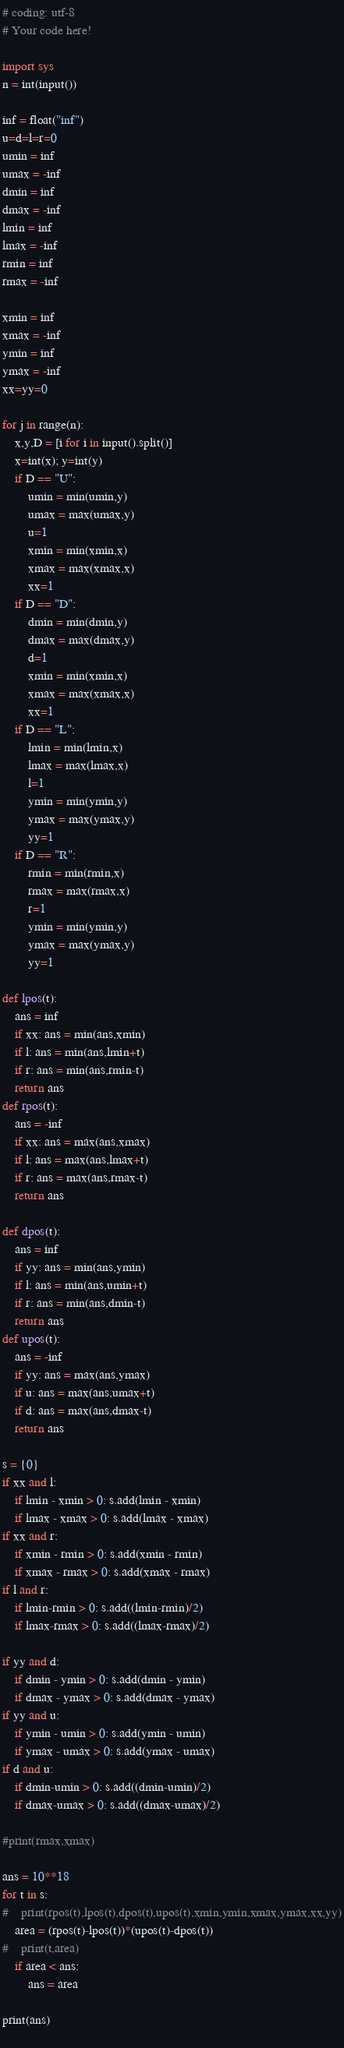Convert code to text. <code><loc_0><loc_0><loc_500><loc_500><_Python_># coding: utf-8
# Your code here!

import sys
n = int(input())

inf = float("inf")
u=d=l=r=0
umin = inf
umax = -inf
dmin = inf
dmax = -inf
lmin = inf
lmax = -inf
rmin = inf
rmax = -inf

xmin = inf
xmax = -inf
ymin = inf
ymax = -inf
xx=yy=0

for j in range(n):
    x,y,D = [i for i in input().split()]
    x=int(x); y=int(y)
    if D == "U":
        umin = min(umin,y)
        umax = max(umax,y)
        u=1
        xmin = min(xmin,x)
        xmax = max(xmax,x)
        xx=1
    if D == "D":
        dmin = min(dmin,y)
        dmax = max(dmax,y)
        d=1
        xmin = min(xmin,x)
        xmax = max(xmax,x)
        xx=1
    if D == "L":
        lmin = min(lmin,x)
        lmax = max(lmax,x)
        l=1
        ymin = min(ymin,y)
        ymax = max(ymax,y)
        yy=1
    if D == "R":
        rmin = min(rmin,x)
        rmax = max(rmax,x)
        r=1
        ymin = min(ymin,y)
        ymax = max(ymax,y)
        yy=1

def lpos(t):
    ans = inf
    if xx: ans = min(ans,xmin)
    if l: ans = min(ans,lmin+t)
    if r: ans = min(ans,rmin-t)
    return ans
def rpos(t):
    ans = -inf
    if xx: ans = max(ans,xmax)
    if l: ans = max(ans,lmax+t)
    if r: ans = max(ans,rmax-t)
    return ans

def dpos(t):
    ans = inf
    if yy: ans = min(ans,ymin)
    if l: ans = min(ans,umin+t)
    if r: ans = min(ans,dmin-t)
    return ans
def upos(t):
    ans = -inf
    if yy: ans = max(ans,ymax)
    if u: ans = max(ans,umax+t)
    if d: ans = max(ans,dmax-t)
    return ans

s = {0}
if xx and l:
    if lmin - xmin > 0: s.add(lmin - xmin)
    if lmax - xmax > 0: s.add(lmax - xmax)
if xx and r:
    if xmin - rmin > 0: s.add(xmin - rmin)
    if xmax - rmax > 0: s.add(xmax - rmax)
if l and r:
    if lmin-rmin > 0: s.add((lmin-rmin)/2)
    if lmax-rmax > 0: s.add((lmax-rmax)/2)

if yy and d:
    if dmin - ymin > 0: s.add(dmin - ymin)
    if dmax - ymax > 0: s.add(dmax - ymax)
if yy and u:
    if ymin - umin > 0: s.add(ymin - umin)
    if ymax - umax > 0: s.add(ymax - umax)
if d and u:
    if dmin-umin > 0: s.add((dmin-umin)/2)
    if dmax-umax > 0: s.add((dmax-umax)/2)
    
#print(rmax,xmax)

ans = 10**18
for t in s:
#    print(rpos(t),lpos(t),dpos(t),upos(t),xmin,ymin,xmax,ymax,xx,yy)
    area = (rpos(t)-lpos(t))*(upos(t)-dpos(t))
#    print(t,area)
    if area < ans:
        ans = area

print(ans)
    










</code> 